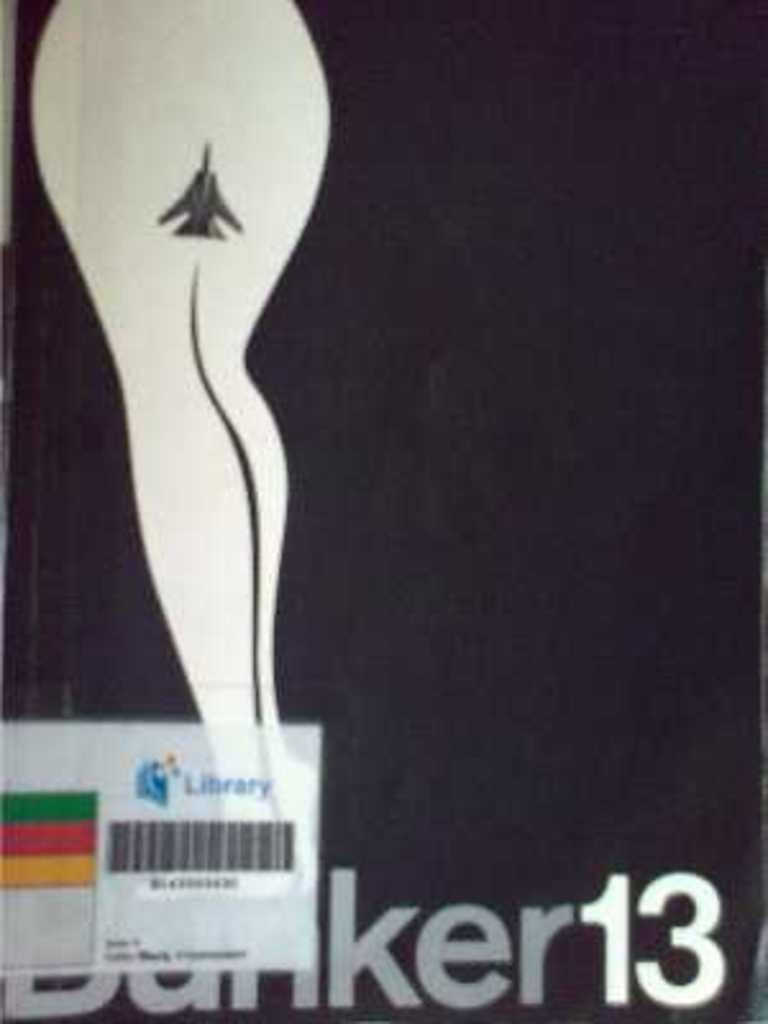Provide a one-sentence caption for the provided image. A libray tag is on the front cover of a book called Banker13. 